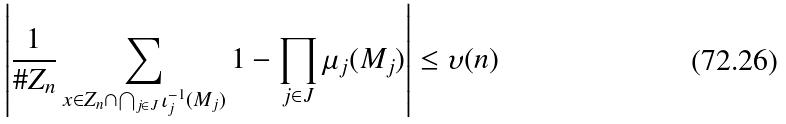Convert formula to latex. <formula><loc_0><loc_0><loc_500><loc_500>\left | \frac { 1 } { \# Z _ { n } } \sum _ { x \in Z _ { n } \cap \bigcap _ { j \in J } \iota _ { j } ^ { - 1 } ( M _ { j } ) } 1 - \prod _ { j \in J } \mu _ { j } ( M _ { j } ) \right | \leq \upsilon ( n )</formula> 